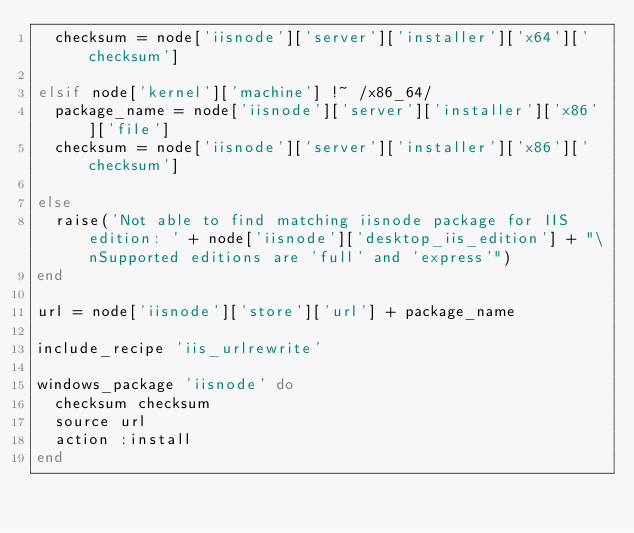<code> <loc_0><loc_0><loc_500><loc_500><_Ruby_>  checksum = node['iisnode']['server']['installer']['x64']['checksum']

elsif node['kernel']['machine'] !~ /x86_64/
  package_name = node['iisnode']['server']['installer']['x86']['file']
  checksum = node['iisnode']['server']['installer']['x86']['checksum']

else
  raise('Not able to find matching iisnode package for IIS edition: ' + node['iisnode']['desktop_iis_edition'] + "\nSupported editions are 'full' and 'express'")
end

url = node['iisnode']['store']['url'] + package_name

include_recipe 'iis_urlrewrite'

windows_package 'iisnode' do
  checksum checksum
  source url
  action :install
end
</code> 